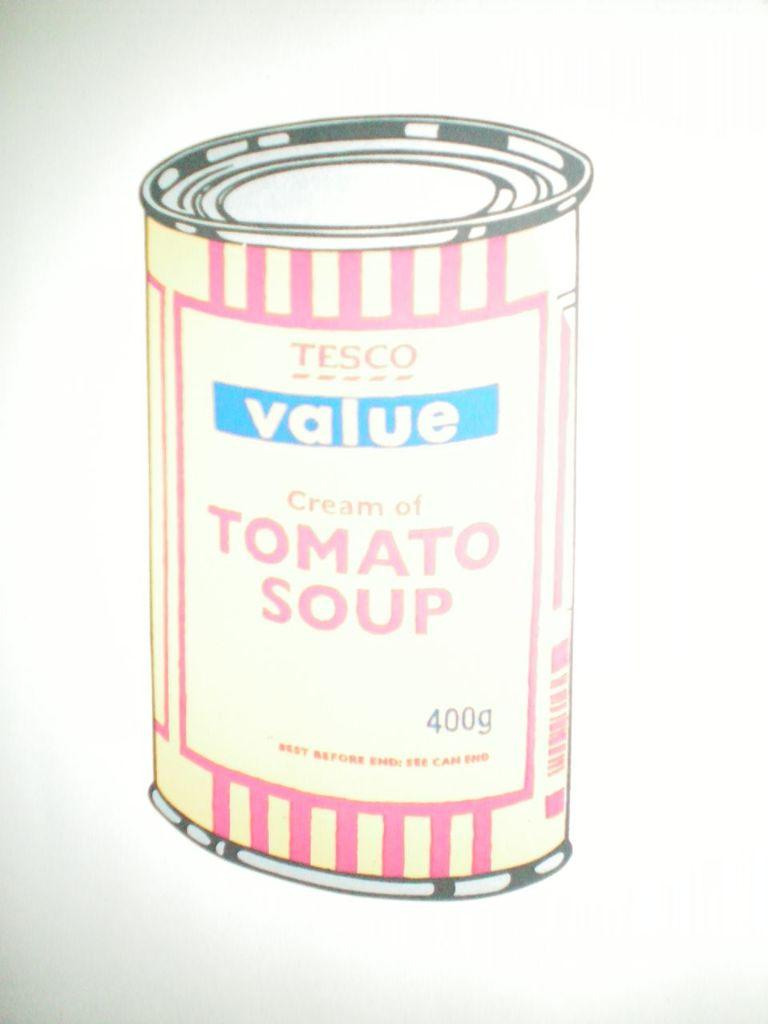<image>
Offer a succinct explanation of the picture presented. A drawing of Tesco cream of tomato soup. 